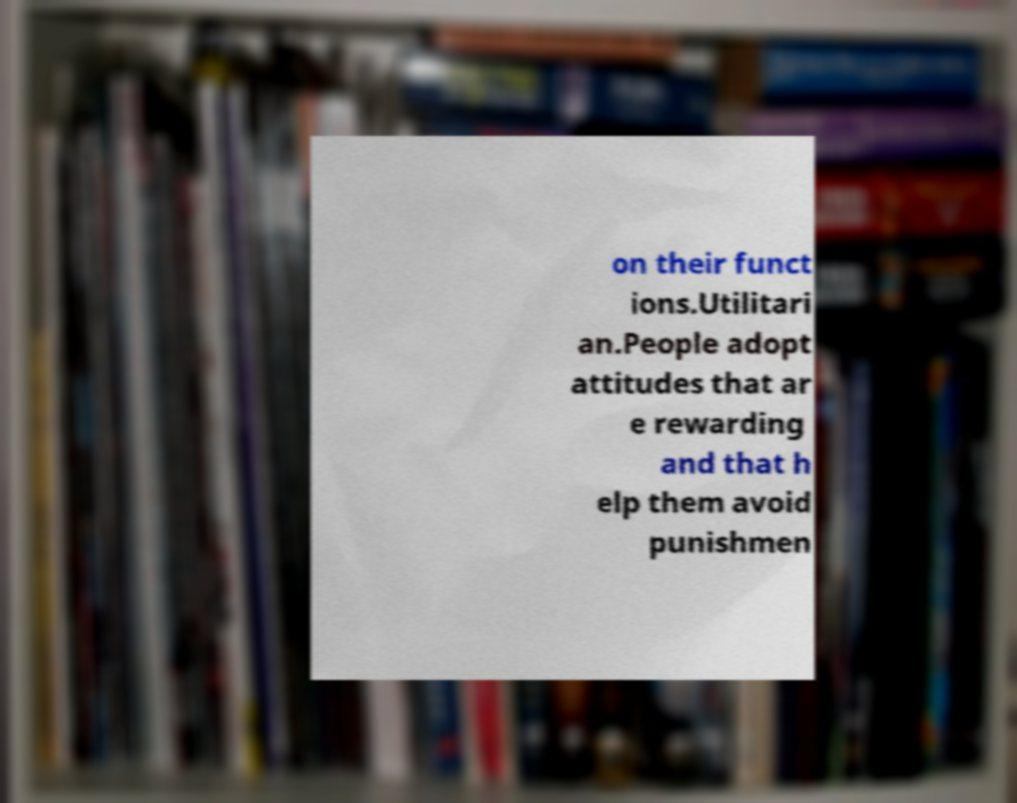Could you assist in decoding the text presented in this image and type it out clearly? on their funct ions.Utilitari an.People adopt attitudes that ar e rewarding and that h elp them avoid punishmen 